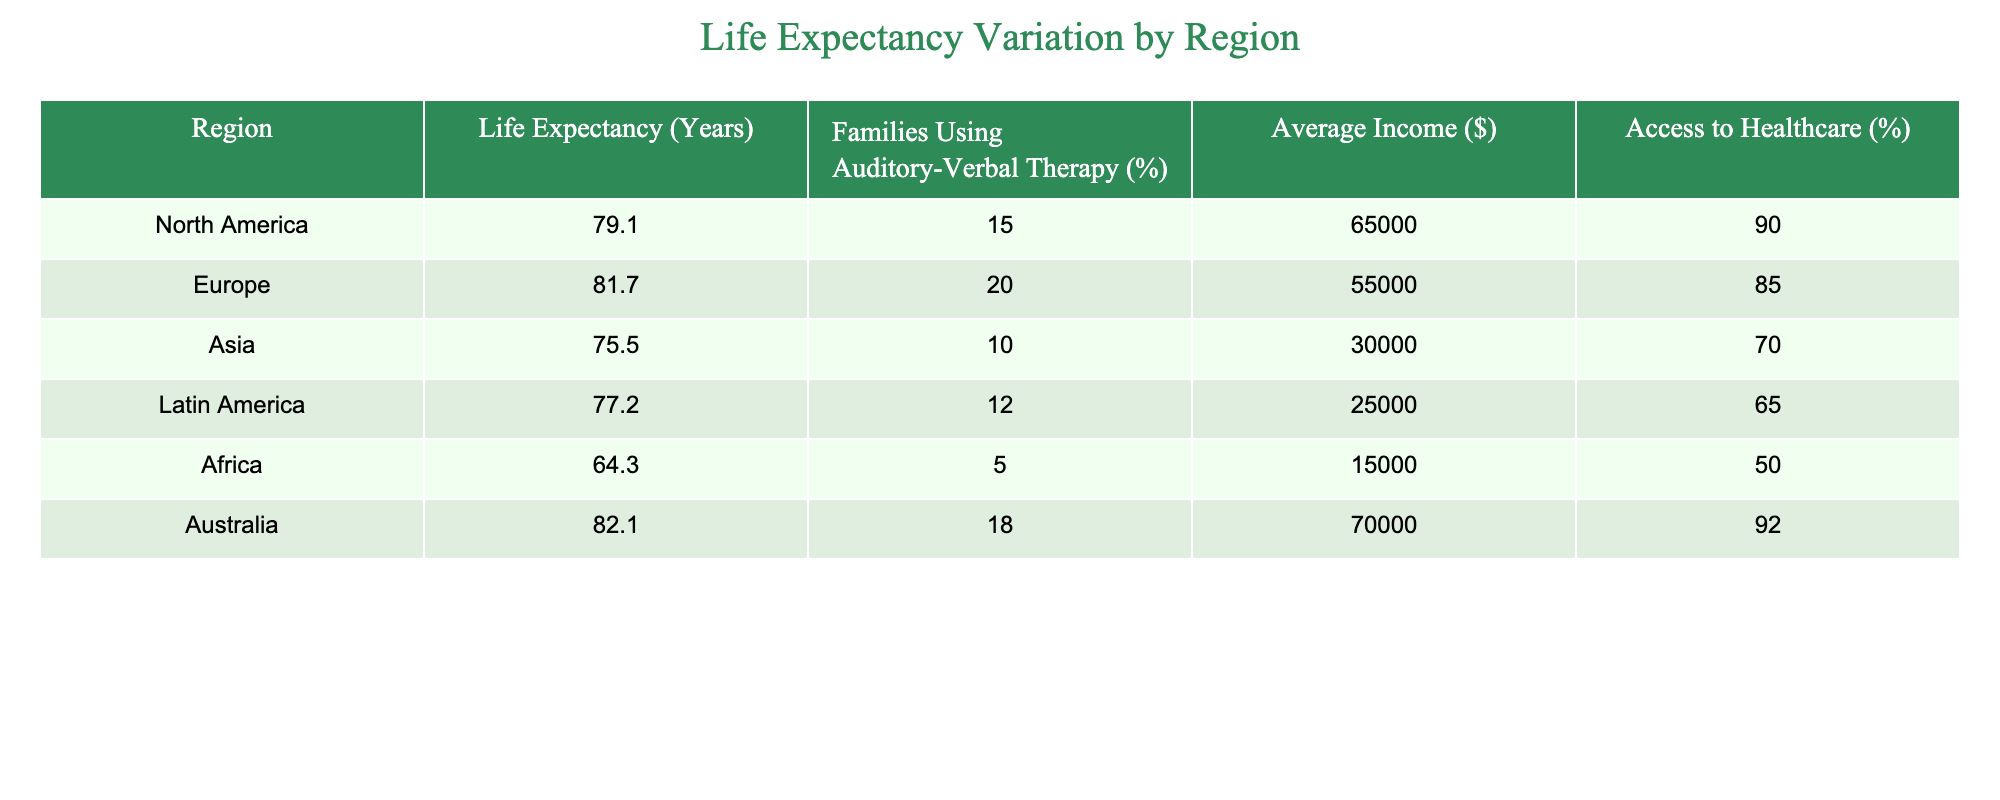What's the life expectancy in Africa? Referring to the table, the life expectancy for the region of Africa is clearly stated as 64.3 years.
Answer: 64.3 years Which region has the highest percentage of families using auditory-verbal therapy? By examining the table, Europe has the highest percentage of families using auditory-verbal therapy at 20%.
Answer: 20% What is the average income of families in North America? The table shows that the average income for families in North America is $65,000.
Answer: $65,000 What is the life expectancy difference between Europe and Asia? To find the difference, subtract Asia's life expectancy (75.5 years) from Europe's (81.7 years). The calculation is 81.7 - 75.5 = 6.2 years difference.
Answer: 6.2 years Is the access to healthcare in Australia higher than in Latin America? From the table, Australia's access to healthcare is 92%, while Latin America's access is 65%. Thus, the statement is true since 92 > 65.
Answer: Yes How many regions have a life expectancy above 78 years? The regions are North America (79.1), Europe (81.7), and Australia (82.1). Counting these gives three regions with a life expectancy above 78 years.
Answer: 3 What is the average life expectancy across all regions listed in the table? To calculate the average, add the life expectancy values (79.1 + 81.7 + 75.5 + 77.2 + 64.3 + 82.1) = 459.9, and then divide by the number of regions (6). Thus, 459.9 / 6 = 76.65 years.
Answer: 76.65 years Which region has both low access to healthcare and the lowest life expectancy? By examining the table, Africa has the lowest life expectancy at 64.3 years and also has low access to healthcare at 50%.
Answer: Africa What is the overall correlation between income and life expectancy based on the regions in the table? Analyzing the data: North America ($65,000, 79.1 years), Europe ($55,000, 81.7 years), Asia ($30,000, 75.5 years), Latin America ($25,000, 77.2 years), Africa ($15,000, 64.3 years), and Australia ($70,000, 82.1 years). From this data, a general correlation can be seen: higher average income regions tend to have higher life expectancy. For instance, Africa has the lowest income and life expectancy. Therefore, the correlation appears positive.
Answer: Positive correlation 